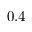<formula> <loc_0><loc_0><loc_500><loc_500>0 . 4</formula> 